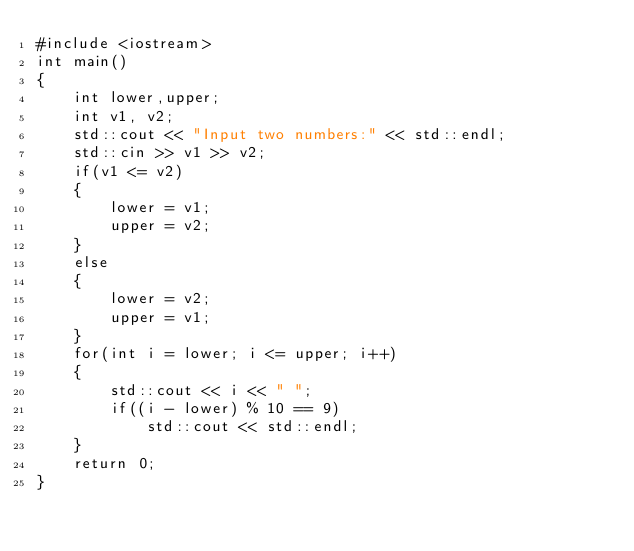Convert code to text. <code><loc_0><loc_0><loc_500><loc_500><_C++_>#include <iostream>
int main()
{
    int lower,upper;
    int v1, v2;
    std::cout << "Input two numbers:" << std::endl;
    std::cin >> v1 >> v2;
    if(v1 <= v2)
    {
        lower = v1;
        upper = v2;
    }
    else
    {
        lower = v2;
        upper = v1;
    }
    for(int i = lower; i <= upper; i++)
    {
        std::cout << i << " ";
        if((i - lower) % 10 == 9)
            std::cout << std::endl;
    }
    return 0;
}
</code> 